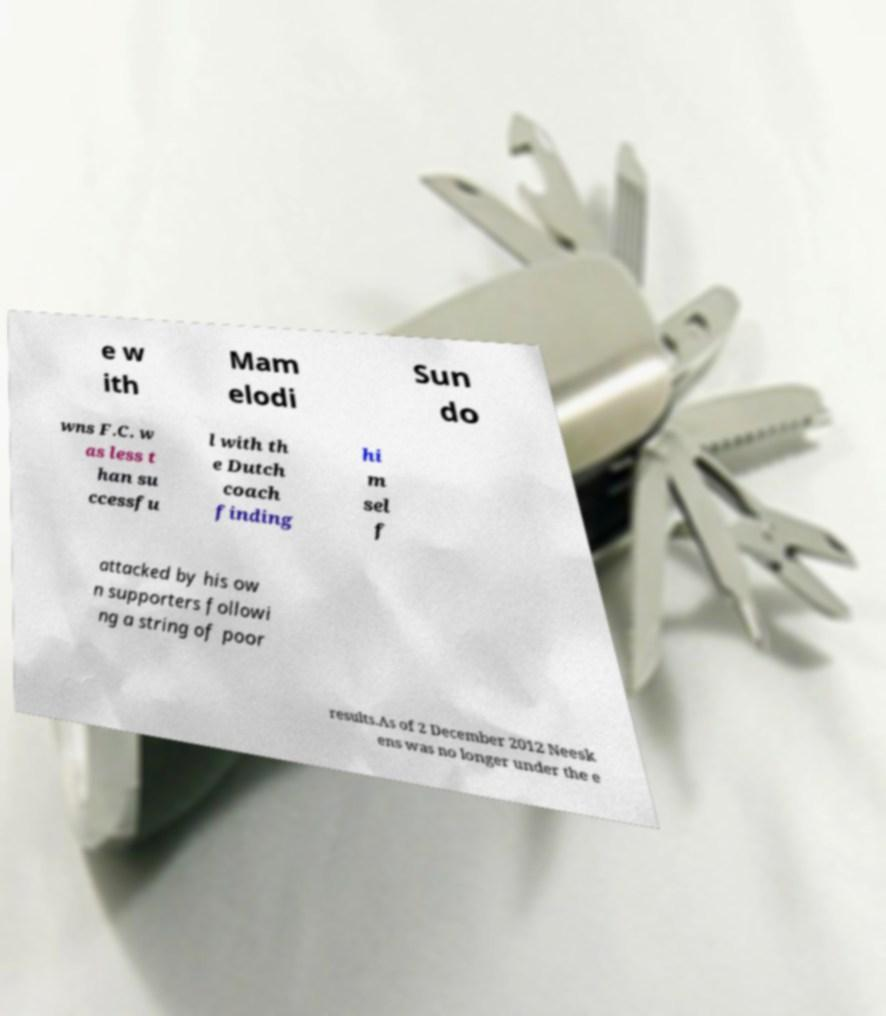There's text embedded in this image that I need extracted. Can you transcribe it verbatim? e w ith Mam elodi Sun do wns F.C. w as less t han su ccessfu l with th e Dutch coach finding hi m sel f attacked by his ow n supporters followi ng a string of poor results.As of 2 December 2012 Neesk ens was no longer under the e 